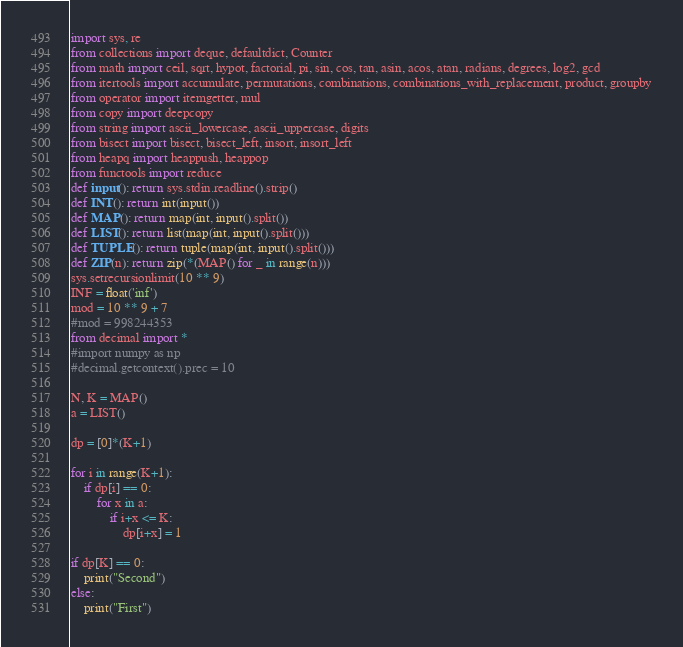Convert code to text. <code><loc_0><loc_0><loc_500><loc_500><_Python_>import sys, re
from collections import deque, defaultdict, Counter
from math import ceil, sqrt, hypot, factorial, pi, sin, cos, tan, asin, acos, atan, radians, degrees, log2, gcd
from itertools import accumulate, permutations, combinations, combinations_with_replacement, product, groupby
from operator import itemgetter, mul
from copy import deepcopy
from string import ascii_lowercase, ascii_uppercase, digits
from bisect import bisect, bisect_left, insort, insort_left
from heapq import heappush, heappop
from functools import reduce
def input(): return sys.stdin.readline().strip()
def INT(): return int(input())
def MAP(): return map(int, input().split())
def LIST(): return list(map(int, input().split()))
def TUPLE(): return tuple(map(int, input().split()))
def ZIP(n): return zip(*(MAP() for _ in range(n)))
sys.setrecursionlimit(10 ** 9)
INF = float('inf')
mod = 10 ** 9 + 7 
#mod = 998244353
from decimal import *
#import numpy as np
#decimal.getcontext().prec = 10

N, K = MAP()
a = LIST()

dp = [0]*(K+1)

for i in range(K+1):
	if dp[i] == 0:
		for x in a:
			if i+x <= K:
				dp[i+x] = 1

if dp[K] == 0:
	print("Second")
else:
	print("First")
</code> 